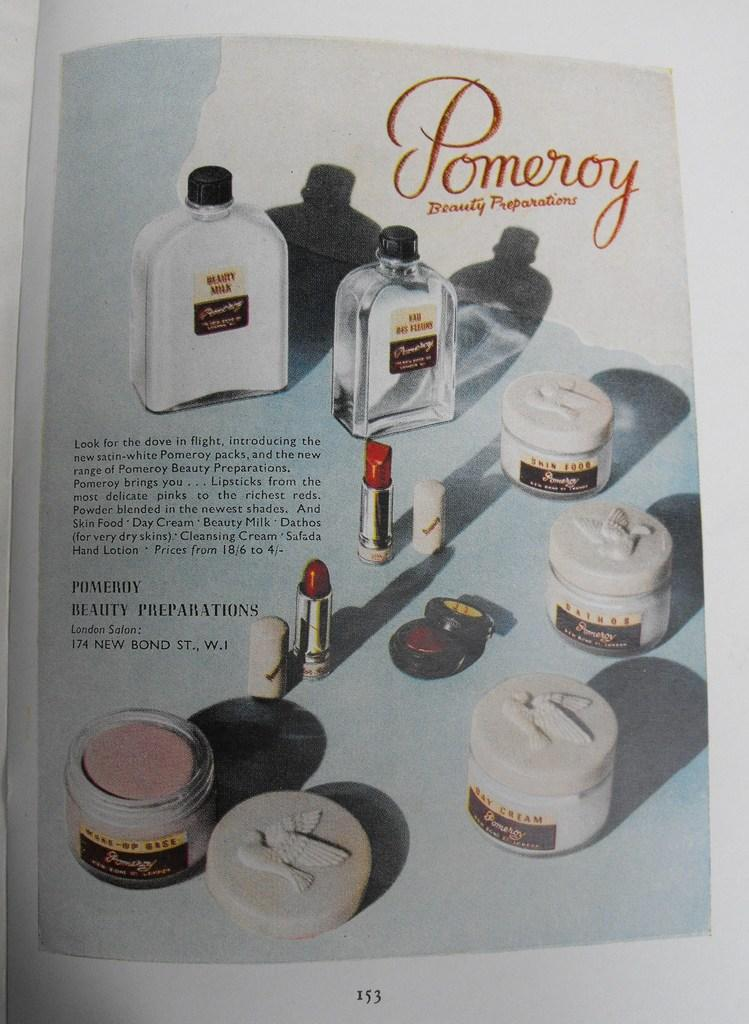<image>
Give a short and clear explanation of the subsequent image. Different types of Pomeroy Beauty Preparations, like lipstick and cream. 